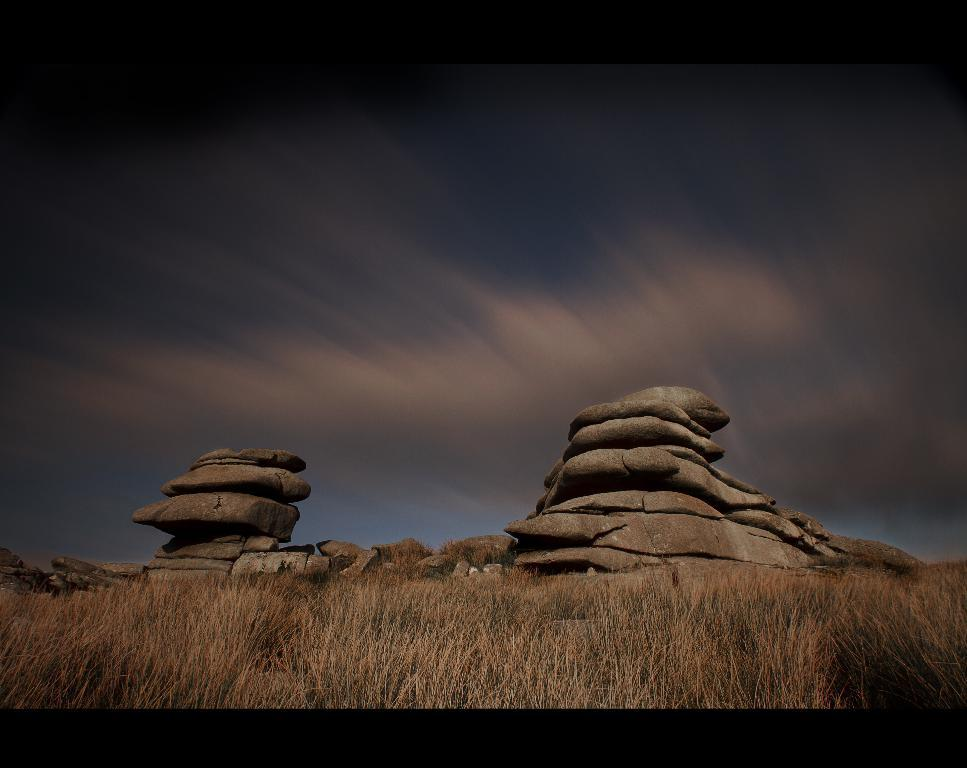What type of vegetation is present in the image? There is grass in the image. What objects can be seen in the middle of the image? There are rocks in the middle of the image. What is visible in the background of the image? There is a sky visible in the background of the image. Can you see any snails helping each other climb the rocks in the image? There are no snails or any indication of helping behavior present in the image. 